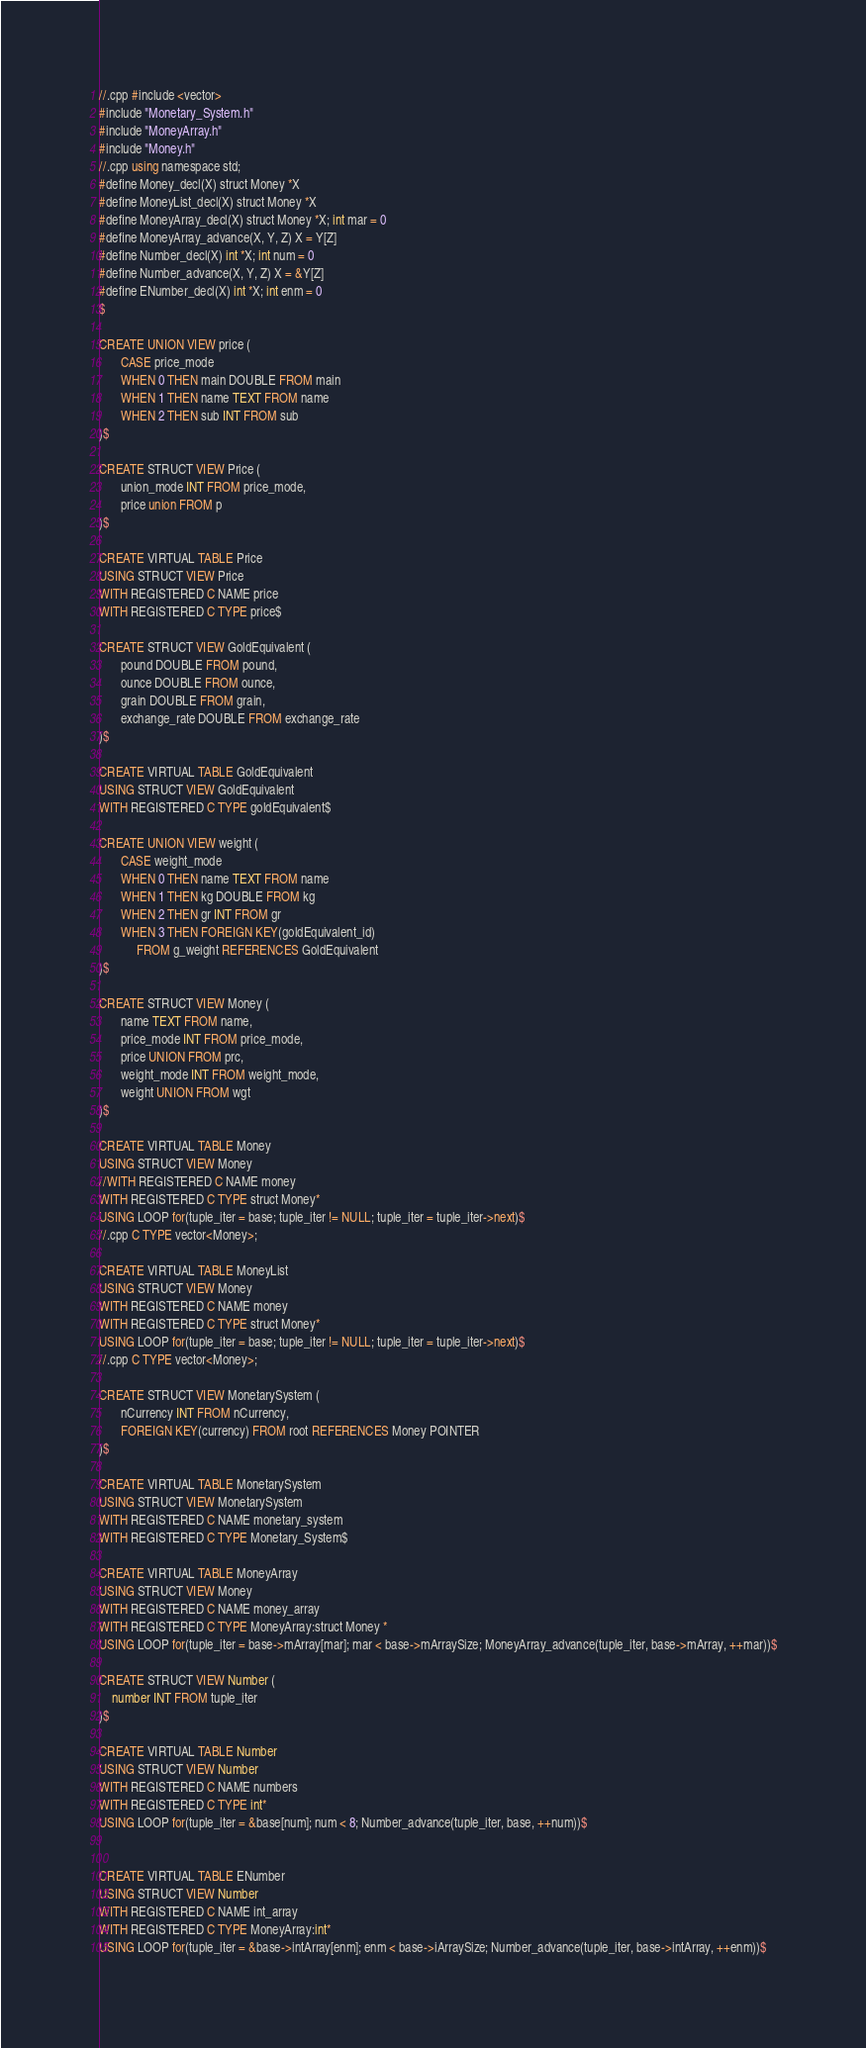Convert code to text. <code><loc_0><loc_0><loc_500><loc_500><_SQL_>//.cpp #include <vector>
#include "Monetary_System.h"
#include "MoneyArray.h"
#include "Money.h"
//.cpp using namespace std;
#define Money_decl(X) struct Money *X
#define MoneyList_decl(X) struct Money *X
#define MoneyArray_decl(X) struct Money *X; int mar = 0
#define MoneyArray_advance(X, Y, Z) X = Y[Z]
#define Number_decl(X) int *X; int num = 0
#define Number_advance(X, Y, Z) X = &Y[Z]
#define ENumber_decl(X) int *X; int enm = 0
$

CREATE UNION VIEW price (
       CASE price_mode
       WHEN 0 THEN main DOUBLE FROM main
       WHEN 1 THEN name TEXT FROM name
       WHEN 2 THEN sub INT FROM sub
)$

CREATE STRUCT VIEW Price (
       union_mode INT FROM price_mode,
       price union FROM p
)$

CREATE VIRTUAL TABLE Price
USING STRUCT VIEW Price
WITH REGISTERED C NAME price
WITH REGISTERED C TYPE price$

CREATE STRUCT VIEW GoldEquivalent (
       pound DOUBLE FROM pound,
       ounce DOUBLE FROM ounce,
       grain DOUBLE FROM grain,
       exchange_rate DOUBLE FROM exchange_rate
)$

CREATE VIRTUAL TABLE GoldEquivalent
USING STRUCT VIEW GoldEquivalent
WITH REGISTERED C TYPE goldEquivalent$

CREATE UNION VIEW weight (
       CASE weight_mode
       WHEN 0 THEN name TEXT FROM name
       WHEN 1 THEN kg DOUBLE FROM kg
       WHEN 2 THEN gr INT FROM gr
       WHEN 3 THEN FOREIGN KEY(goldEquivalent_id) 
       	    FROM g_weight REFERENCES GoldEquivalent
)$

CREATE STRUCT VIEW Money (
       name TEXT FROM name,
       price_mode INT FROM price_mode,
       price UNION FROM prc,
       weight_mode INT FROM weight_mode,
       weight UNION FROM wgt
)$

CREATE VIRTUAL TABLE Money
USING STRUCT VIEW Money
//WITH REGISTERED C NAME money
WITH REGISTERED C TYPE struct Money*
USING LOOP for(tuple_iter = base; tuple_iter != NULL; tuple_iter = tuple_iter->next)$
//.cpp C TYPE vector<Money>;

CREATE VIRTUAL TABLE MoneyList
USING STRUCT VIEW Money
WITH REGISTERED C NAME money
WITH REGISTERED C TYPE struct Money*
USING LOOP for(tuple_iter = base; tuple_iter != NULL; tuple_iter = tuple_iter->next)$ 
//.cpp C TYPE vector<Money>;

CREATE STRUCT VIEW MonetarySystem (
       nCurrency INT FROM nCurrency,
       FOREIGN KEY(currency) FROM root REFERENCES Money POINTER
)$

CREATE VIRTUAL TABLE MonetarySystem
USING STRUCT VIEW MonetarySystem
WITH REGISTERED C NAME monetary_system
WITH REGISTERED C TYPE Monetary_System$

CREATE VIRTUAL TABLE MoneyArray
USING STRUCT VIEW Money
WITH REGISTERED C NAME money_array
WITH REGISTERED C TYPE MoneyArray:struct Money *
USING LOOP for(tuple_iter = base->mArray[mar]; mar < base->mArraySize; MoneyArray_advance(tuple_iter, base->mArray, ++mar))$

CREATE STRUCT VIEW Number (
	number INT FROM tuple_iter
)$

CREATE VIRTUAL TABLE Number
USING STRUCT VIEW Number
WITH REGISTERED C NAME numbers
WITH REGISTERED C TYPE int*
USING LOOP for(tuple_iter = &base[num]; num < 8; Number_advance(tuple_iter, base, ++num))$


CREATE VIRTUAL TABLE ENumber
USING STRUCT VIEW Number
WITH REGISTERED C NAME int_array
WITH REGISTERED C TYPE MoneyArray:int*
USING LOOP for(tuple_iter = &base->intArray[enm]; enm < base->iArraySize; Number_advance(tuple_iter, base->intArray, ++enm))$
</code> 